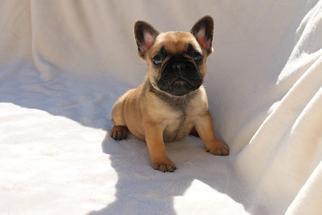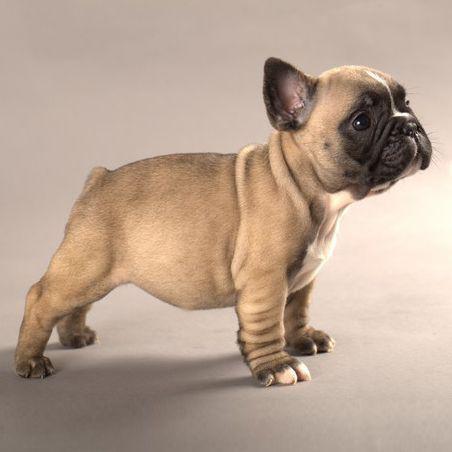The first image is the image on the left, the second image is the image on the right. Analyze the images presented: Is the assertion "None of the dogs pictured are wearing collars." valid? Answer yes or no. Yes. The first image is the image on the left, the second image is the image on the right. Assess this claim about the two images: "Each image includes one buff-beige bulldog puppy, and the puppy on the left is sitting on fabric, while the puppy on the right is standing on all fours.". Correct or not? Answer yes or no. Yes. 